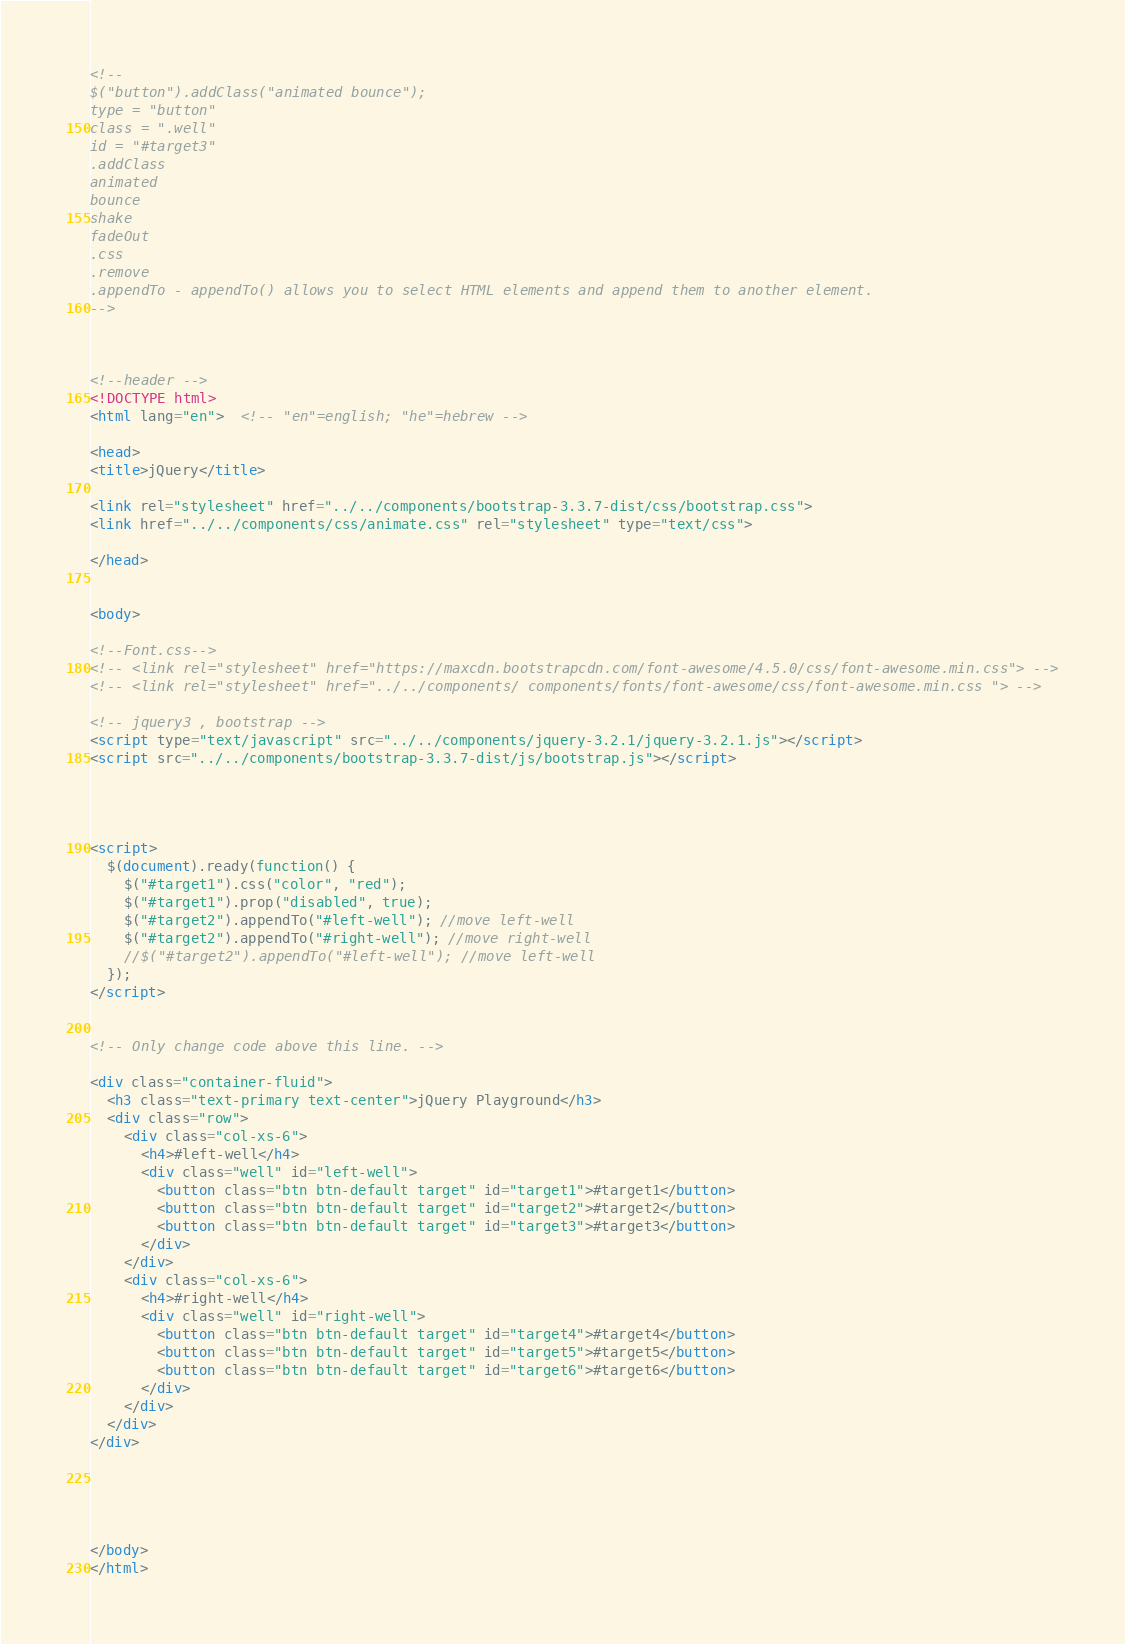<code> <loc_0><loc_0><loc_500><loc_500><_HTML_>
<!--
$("button").addClass("animated bounce");
type = "button"
class = ".well"
id = "#target3"
.addClass
animated
bounce
shake
fadeOut
.css
.remove
.appendTo - appendTo() allows you to select HTML elements and append them to another element.
-->



<!--header -->
<!DOCTYPE html>
<html lang="en">  <!-- "en"=english; "he"=hebrew -->

<head>
<title>jQuery</title>

<link rel="stylesheet" href="../../components/bootstrap-3.3.7-dist/css/bootstrap.css">
<link href="../../components/css/animate.css" rel="stylesheet" type="text/css">

</head>


<body>

<!--Font.css-->
<!-- <link rel="stylesheet" href="https://maxcdn.bootstrapcdn.com/font-awesome/4.5.0/css/font-awesome.min.css"> -->
<!-- <link rel="stylesheet" href="../../components/ components/fonts/font-awesome/css/font-awesome.min.css "> -->

<!-- jquery3 , bootstrap -->
<script type="text/javascript" src="../../components/jquery-3.2.1/jquery-3.2.1.js"></script>
<script src="../../components/bootstrap-3.3.7-dist/js/bootstrap.js"></script>




<script>
  $(document).ready(function() {
    $("#target1").css("color", "red");
    $("#target1").prop("disabled", true);
    $("#target2").appendTo("#left-well"); //move left-well
    $("#target2").appendTo("#right-well"); //move right-well
    //$("#target2").appendTo("#left-well"); //move left-well
  });
</script>


<!-- Only change code above this line. -->

<div class="container-fluid">
  <h3 class="text-primary text-center">jQuery Playground</h3>
  <div class="row">
    <div class="col-xs-6">
      <h4>#left-well</h4>
      <div class="well" id="left-well">
        <button class="btn btn-default target" id="target1">#target1</button>
        <button class="btn btn-default target" id="target2">#target2</button>
        <button class="btn btn-default target" id="target3">#target3</button>
      </div>
    </div>
    <div class="col-xs-6">
      <h4>#right-well</h4>
      <div class="well" id="right-well">
        <button class="btn btn-default target" id="target4">#target4</button>
        <button class="btn btn-default target" id="target5">#target5</button>
        <button class="btn btn-default target" id="target6">#target6</button>
      </div>
    </div>
  </div>
</div>





</body>
</html>
</code> 